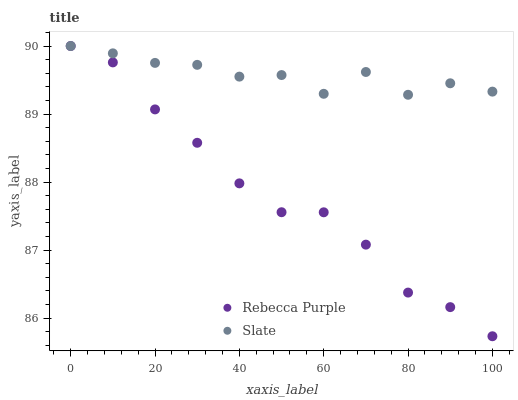Does Rebecca Purple have the minimum area under the curve?
Answer yes or no. Yes. Does Slate have the maximum area under the curve?
Answer yes or no. Yes. Does Rebecca Purple have the maximum area under the curve?
Answer yes or no. No. Is Rebecca Purple the smoothest?
Answer yes or no. Yes. Is Slate the roughest?
Answer yes or no. Yes. Is Rebecca Purple the roughest?
Answer yes or no. No. Does Rebecca Purple have the lowest value?
Answer yes or no. Yes. Does Rebecca Purple have the highest value?
Answer yes or no. Yes. Does Rebecca Purple intersect Slate?
Answer yes or no. Yes. Is Rebecca Purple less than Slate?
Answer yes or no. No. Is Rebecca Purple greater than Slate?
Answer yes or no. No. 